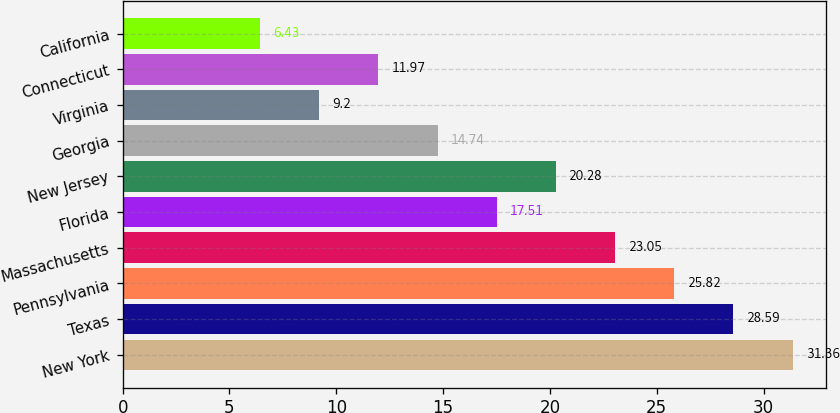<chart> <loc_0><loc_0><loc_500><loc_500><bar_chart><fcel>New York<fcel>Texas<fcel>Pennsylvania<fcel>Massachusetts<fcel>Florida<fcel>New Jersey<fcel>Georgia<fcel>Virginia<fcel>Connecticut<fcel>California<nl><fcel>31.36<fcel>28.59<fcel>25.82<fcel>23.05<fcel>17.51<fcel>20.28<fcel>14.74<fcel>9.2<fcel>11.97<fcel>6.43<nl></chart> 